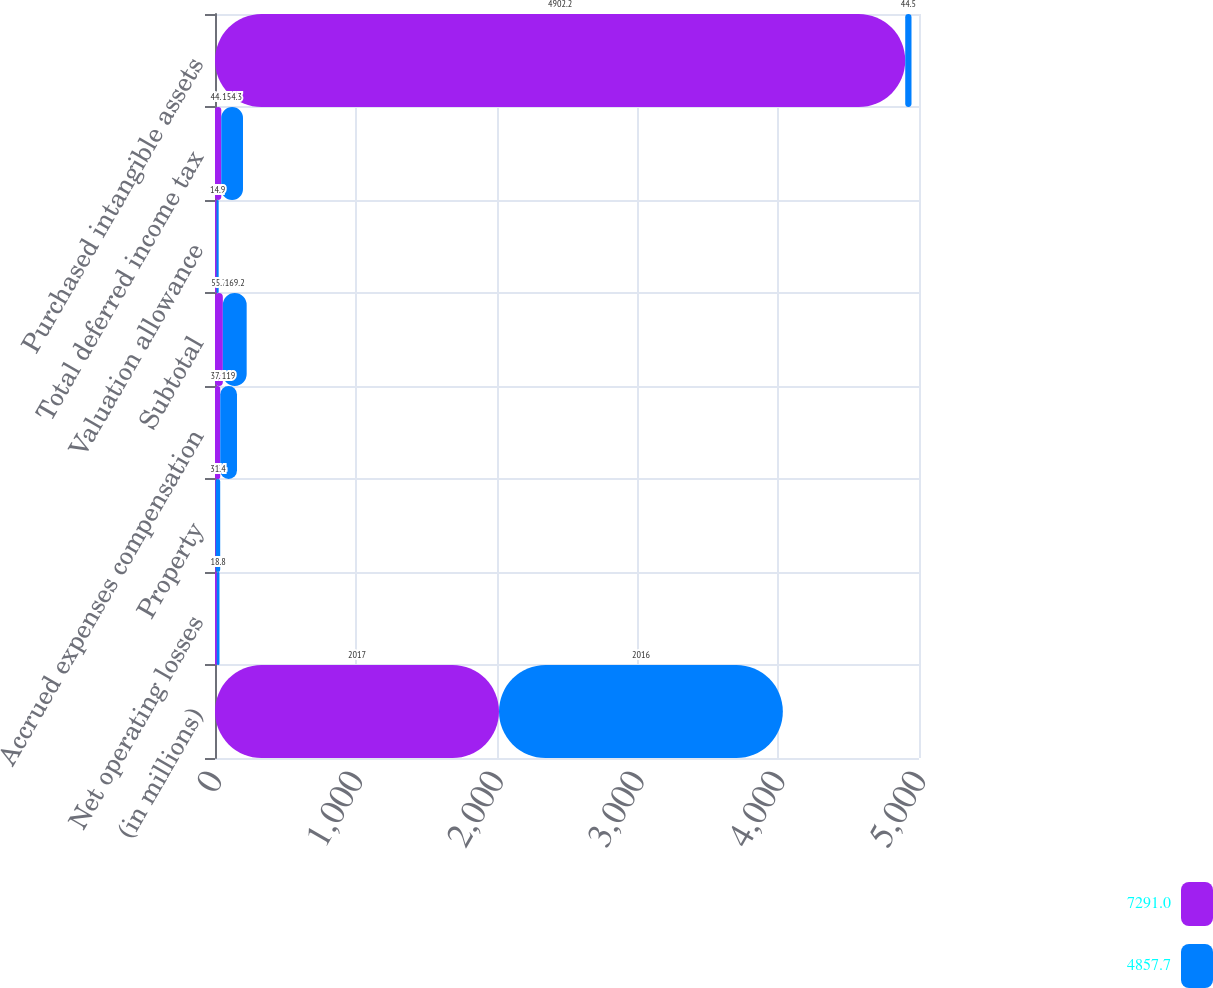Convert chart. <chart><loc_0><loc_0><loc_500><loc_500><stacked_bar_chart><ecel><fcel>(in millions)<fcel>Net operating losses<fcel>Property<fcel>Accrued expenses compensation<fcel>Subtotal<fcel>Valuation allowance<fcel>Total deferred income tax<fcel>Purchased intangible assets<nl><fcel>7291<fcel>2017<fcel>13<fcel>5.5<fcel>37.2<fcel>55.7<fcel>11.2<fcel>44.5<fcel>4902.2<nl><fcel>4857.7<fcel>2016<fcel>18.8<fcel>31.4<fcel>119<fcel>169.2<fcel>14.9<fcel>154.3<fcel>44.5<nl></chart> 